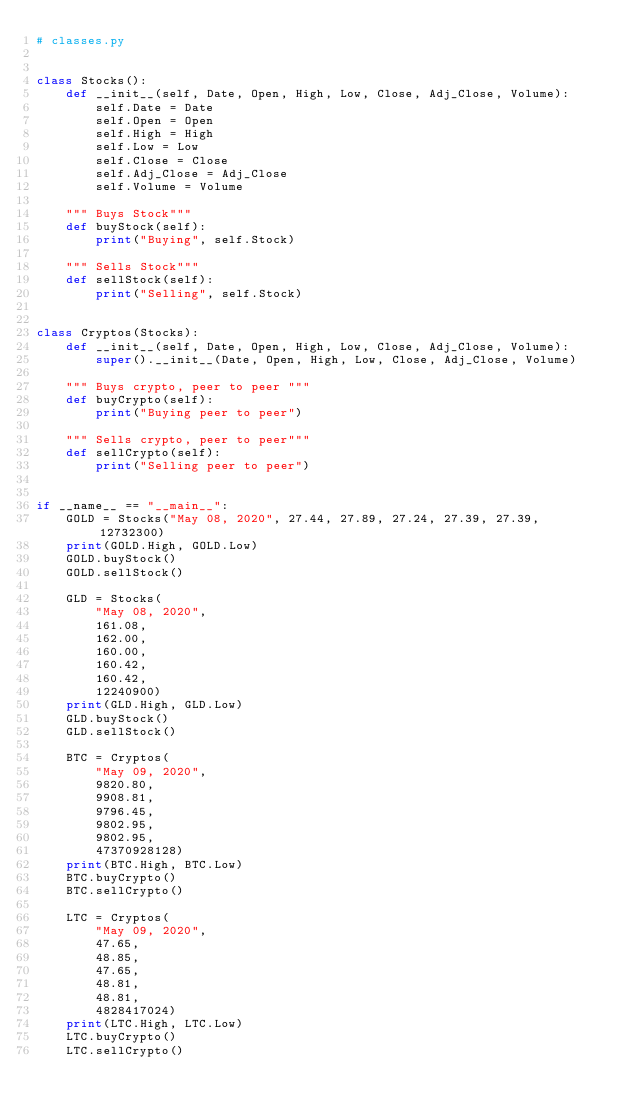Convert code to text. <code><loc_0><loc_0><loc_500><loc_500><_Python_># classes.py


class Stocks():
    def __init__(self, Date, Open, High, Low, Close, Adj_Close, Volume):
        self.Date = Date
        self.Open = Open
        self.High = High
        self.Low = Low
        self.Close = Close
        self.Adj_Close = Adj_Close
        self.Volume = Volume

    """ Buys Stock"""
    def buyStock(self):
        print("Buying", self.Stock)

    """ Sells Stock"""
    def sellStock(self):
        print("Selling", self.Stock)


class Cryptos(Stocks):
    def __init__(self, Date, Open, High, Low, Close, Adj_Close, Volume):
        super().__init__(Date, Open, High, Low, Close, Adj_Close, Volume)

    """ Buys crypto, peer to peer """
    def buyCrypto(self):
        print("Buying peer to peer")
    
    """ Sells crypto, peer to peer"""
    def sellCrypto(self):
        print("Selling peer to peer")


if __name__ == "__main__":
    GOLD = Stocks("May 08, 2020", 27.44, 27.89, 27.24, 27.39, 27.39, 12732300)
    print(GOLD.High, GOLD.Low)
    GOLD.buyStock()
    GOLD.sellStock()

    GLD = Stocks(
        "May 08, 2020",
        161.08,
        162.00,
        160.00,
        160.42,
        160.42,
        12240900)
    print(GLD.High, GLD.Low)
    GLD.buyStock()
    GLD.sellStock()

    BTC = Cryptos(
        "May 09, 2020",
        9820.80,
        9908.81,
        9796.45,
        9802.95,
        9802.95,
        47370928128)
    print(BTC.High, BTC.Low)
    BTC.buyCrypto()
    BTC.sellCrypto()

    LTC = Cryptos(
        "May 09, 2020",
        47.65,
        48.85,
        47.65,
        48.81,
        48.81,
        4828417024)
    print(LTC.High, LTC.Low)
    LTC.buyCrypto()
    LTC.sellCrypto()
</code> 